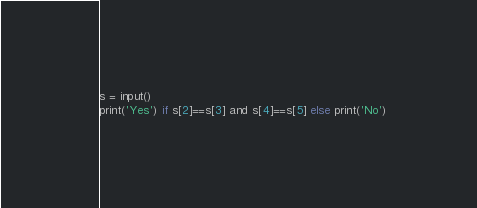Convert code to text. <code><loc_0><loc_0><loc_500><loc_500><_Python_>s = input()
print('Yes') if s[2]==s[3] and s[4]==s[5] else print('No')</code> 